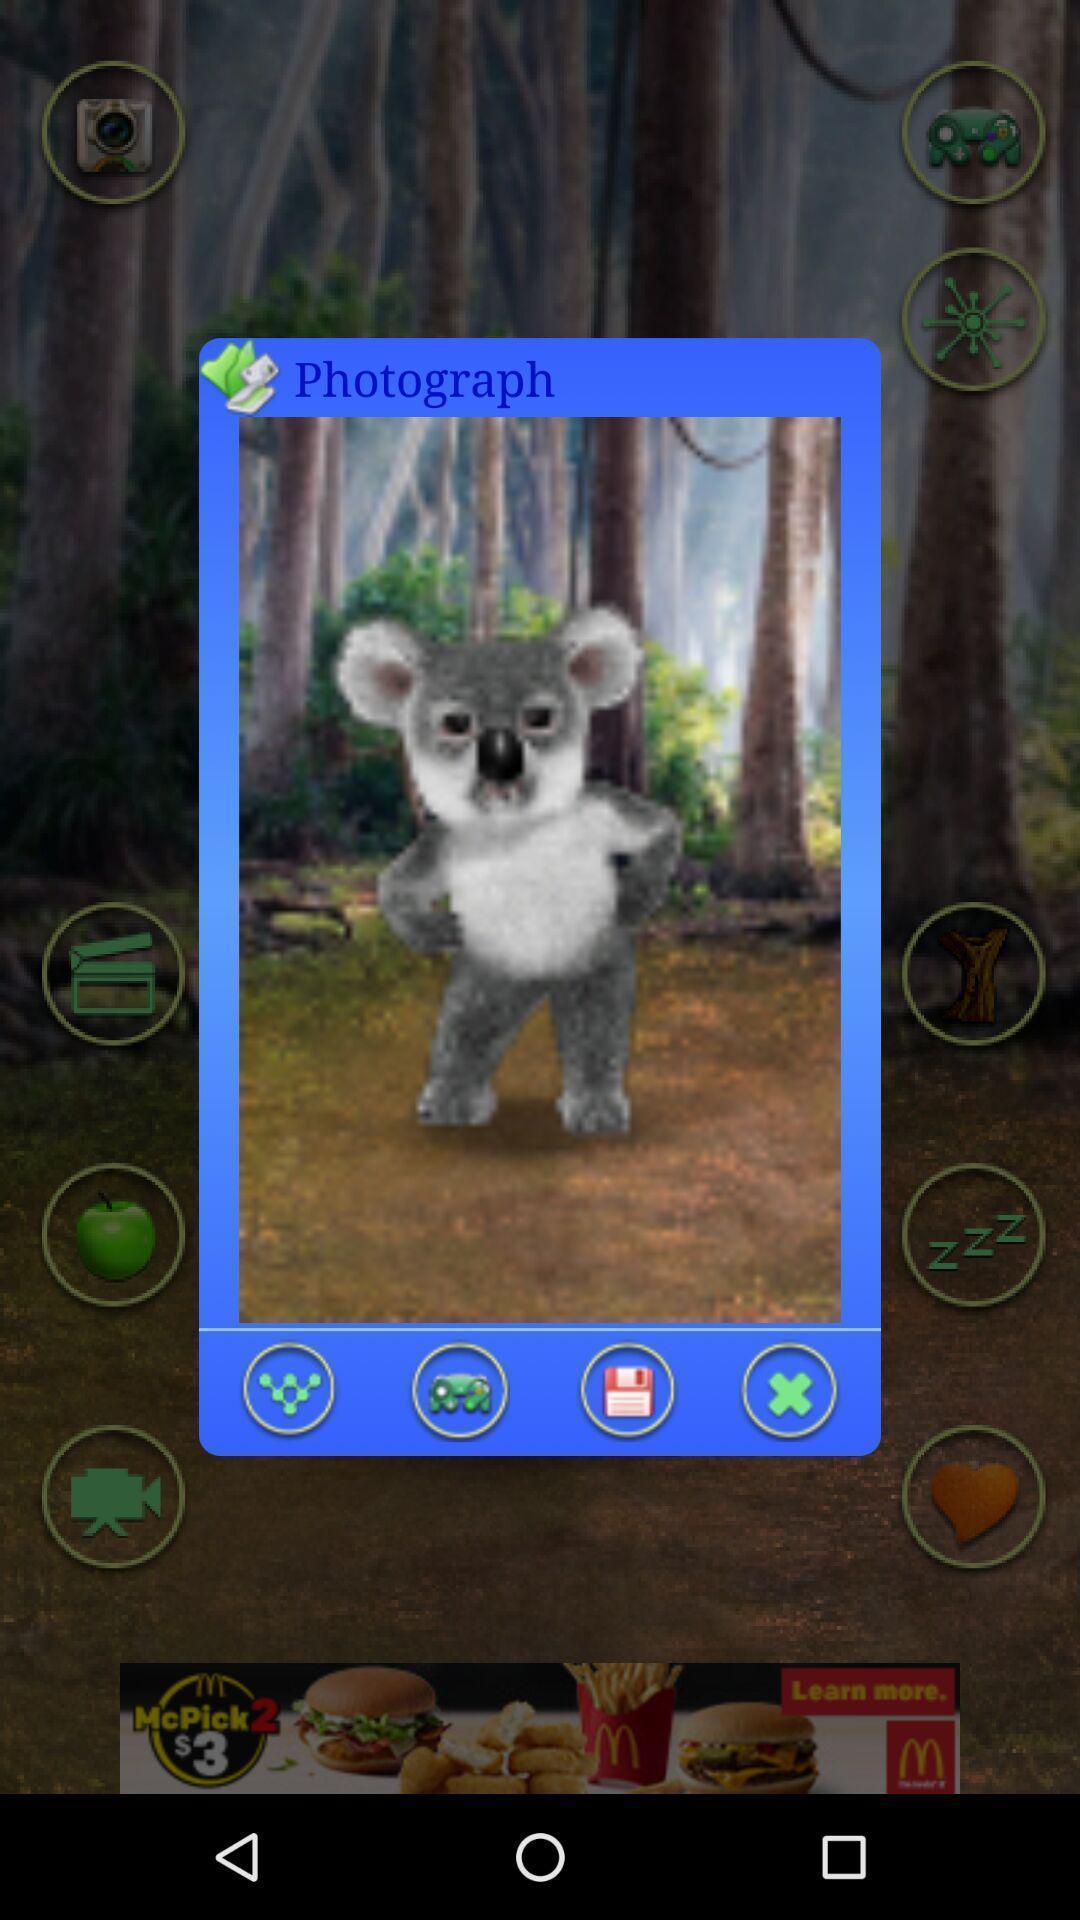Provide a detailed account of this screenshot. Screen displaying a picture with multiple control options. 